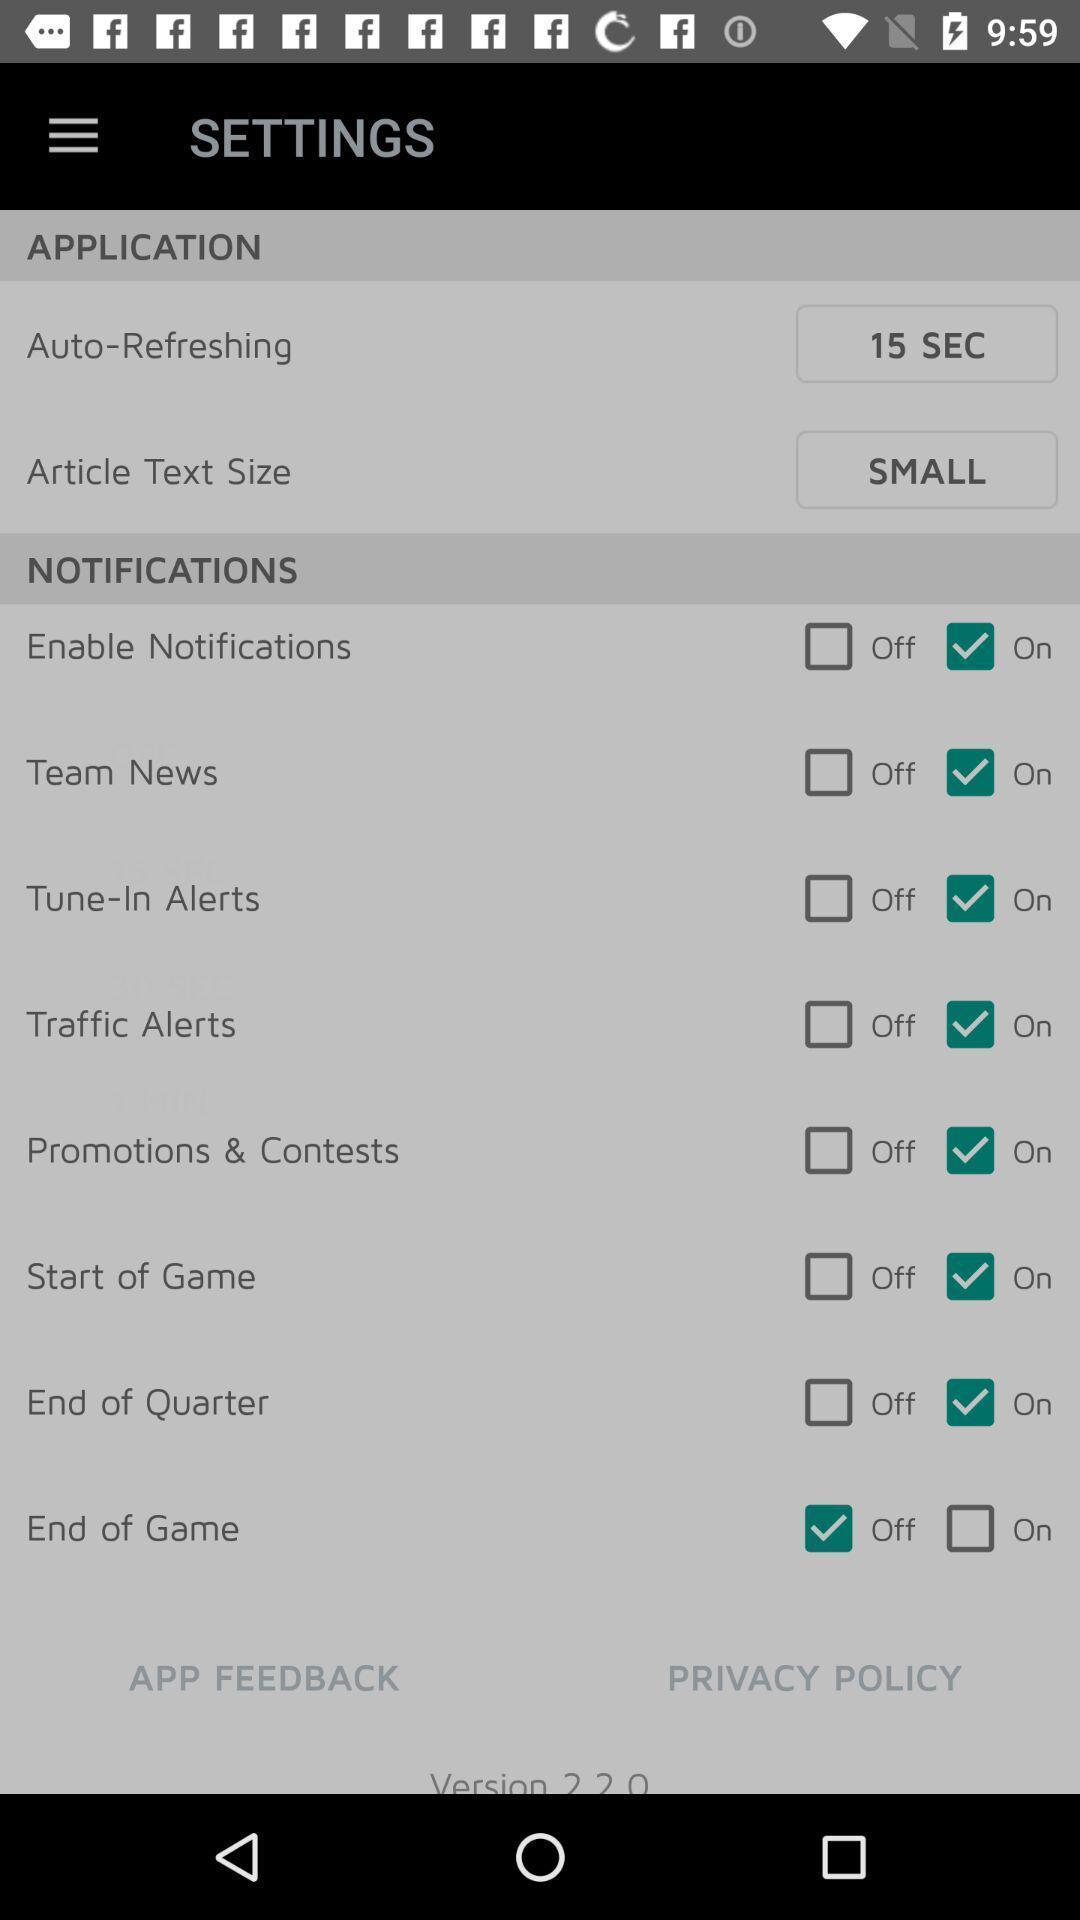Tell me what you see in this picture. Page showing different options in settings. 